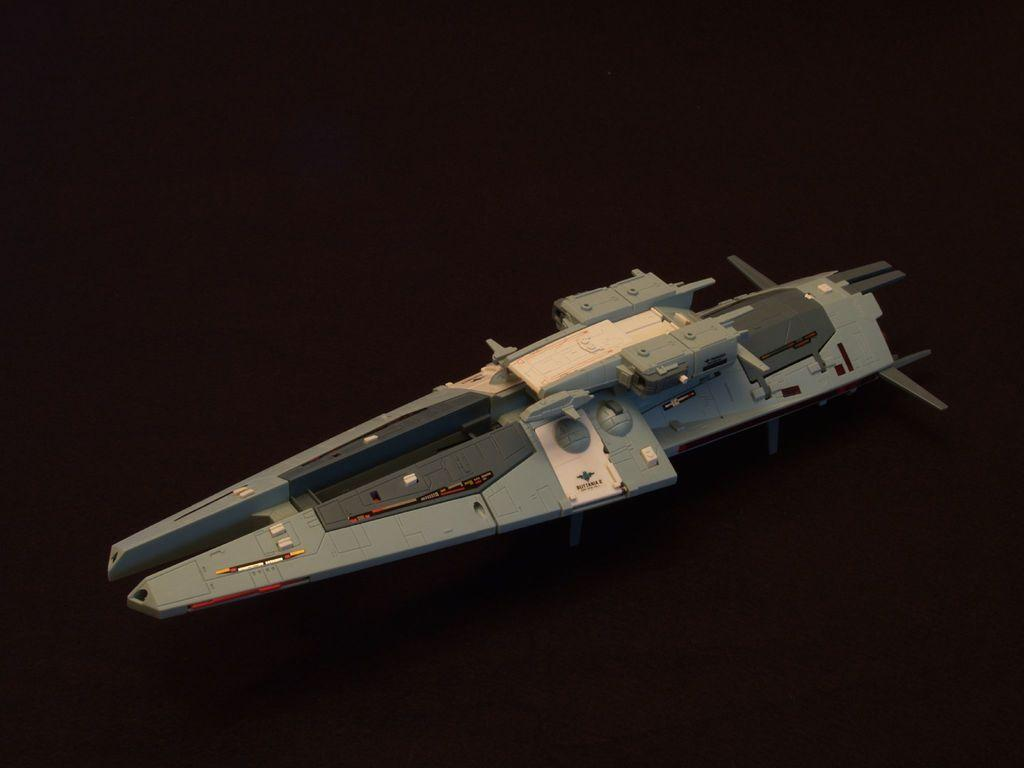What is the main object in the image? There is a device in the image. Where is the device located? The device is placed on a surface. What can be observed about the background of the image? The background of the image is dark in color. What type of tray is used to hold the device in the image? A: There is no tray present in the image; the device is placed directly on a surface. 